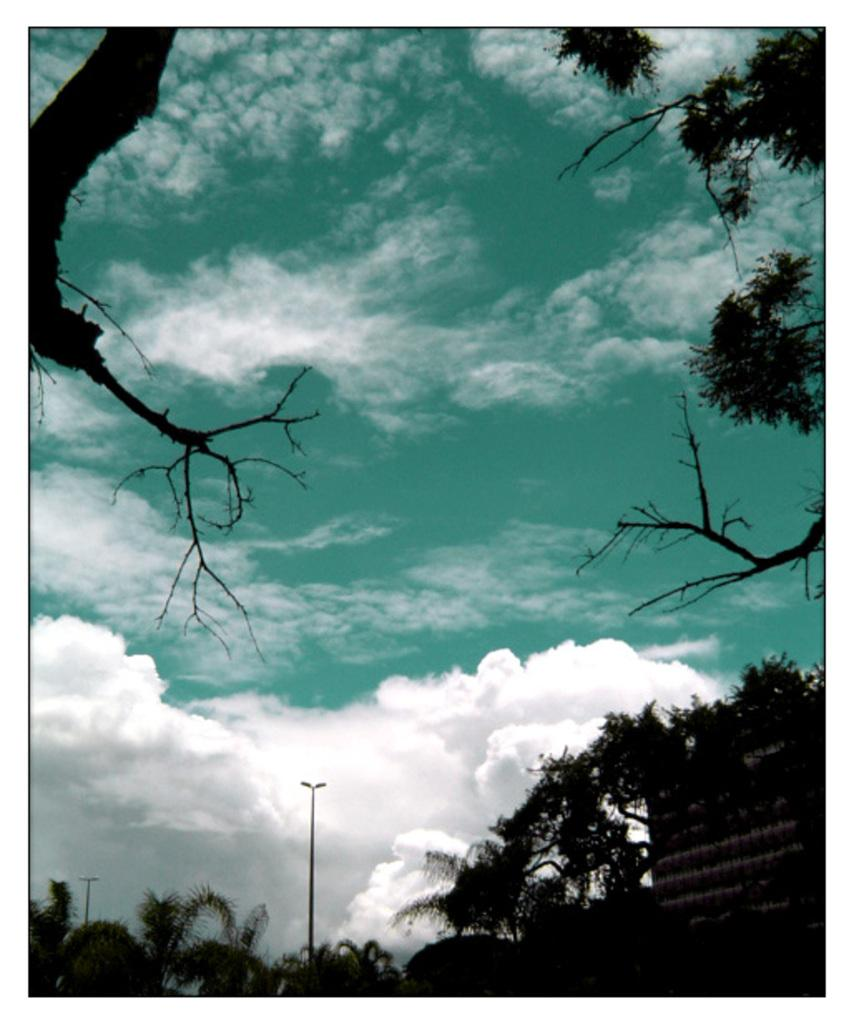What is located in the middle of the image? There are trees, street lights, and a wall in the middle of the image. What can be seen above the middle section of the image? The sky is visible at the top of the image. What is present in the sky? Clouds are present in the sky. What type of voice can be heard coming from the trees in the image? There is no voice present in the image; it features trees, street lights, and a wall. What kind of pain is being experienced by the wall in the image? There is no indication of pain in the image; it is a static representation of the wall, trees, and street lights. 